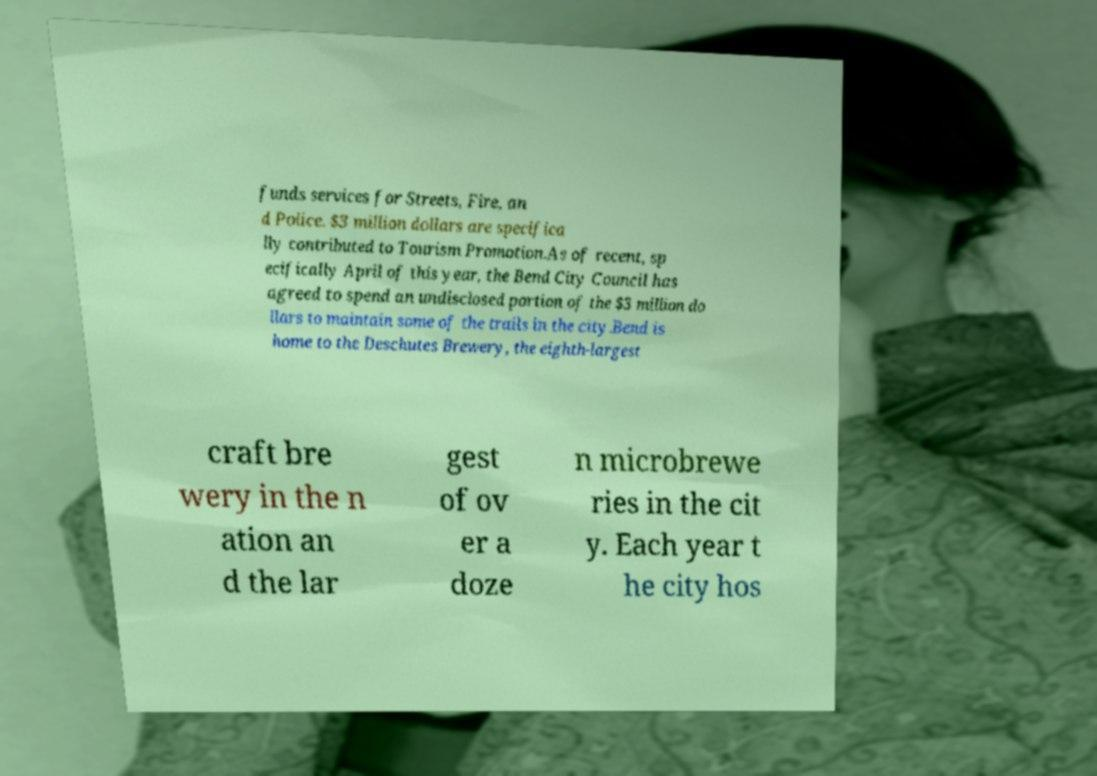Can you accurately transcribe the text from the provided image for me? funds services for Streets, Fire, an d Police. $3 million dollars are specifica lly contributed to Tourism Promotion.As of recent, sp ecifically April of this year, the Bend City Council has agreed to spend an undisclosed portion of the $3 million do llars to maintain some of the trails in the city.Bend is home to the Deschutes Brewery, the eighth-largest craft bre wery in the n ation an d the lar gest of ov er a doze n microbrewe ries in the cit y. Each year t he city hos 